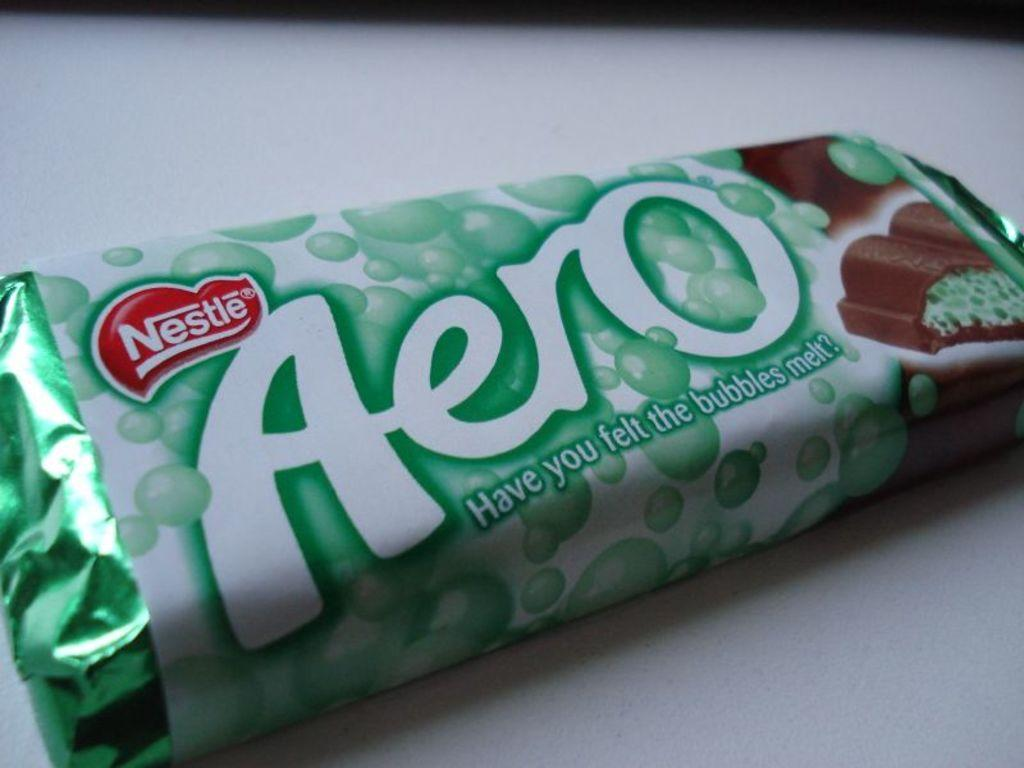What is the color of the packet in the image? The packet in the image is green and white in color. Where is the packet located in the image? The packet is placed on a table in the image. What is the color of the table? The table is white in color. How many women are in the image holding a whip? There are no women or whips present in the image. 